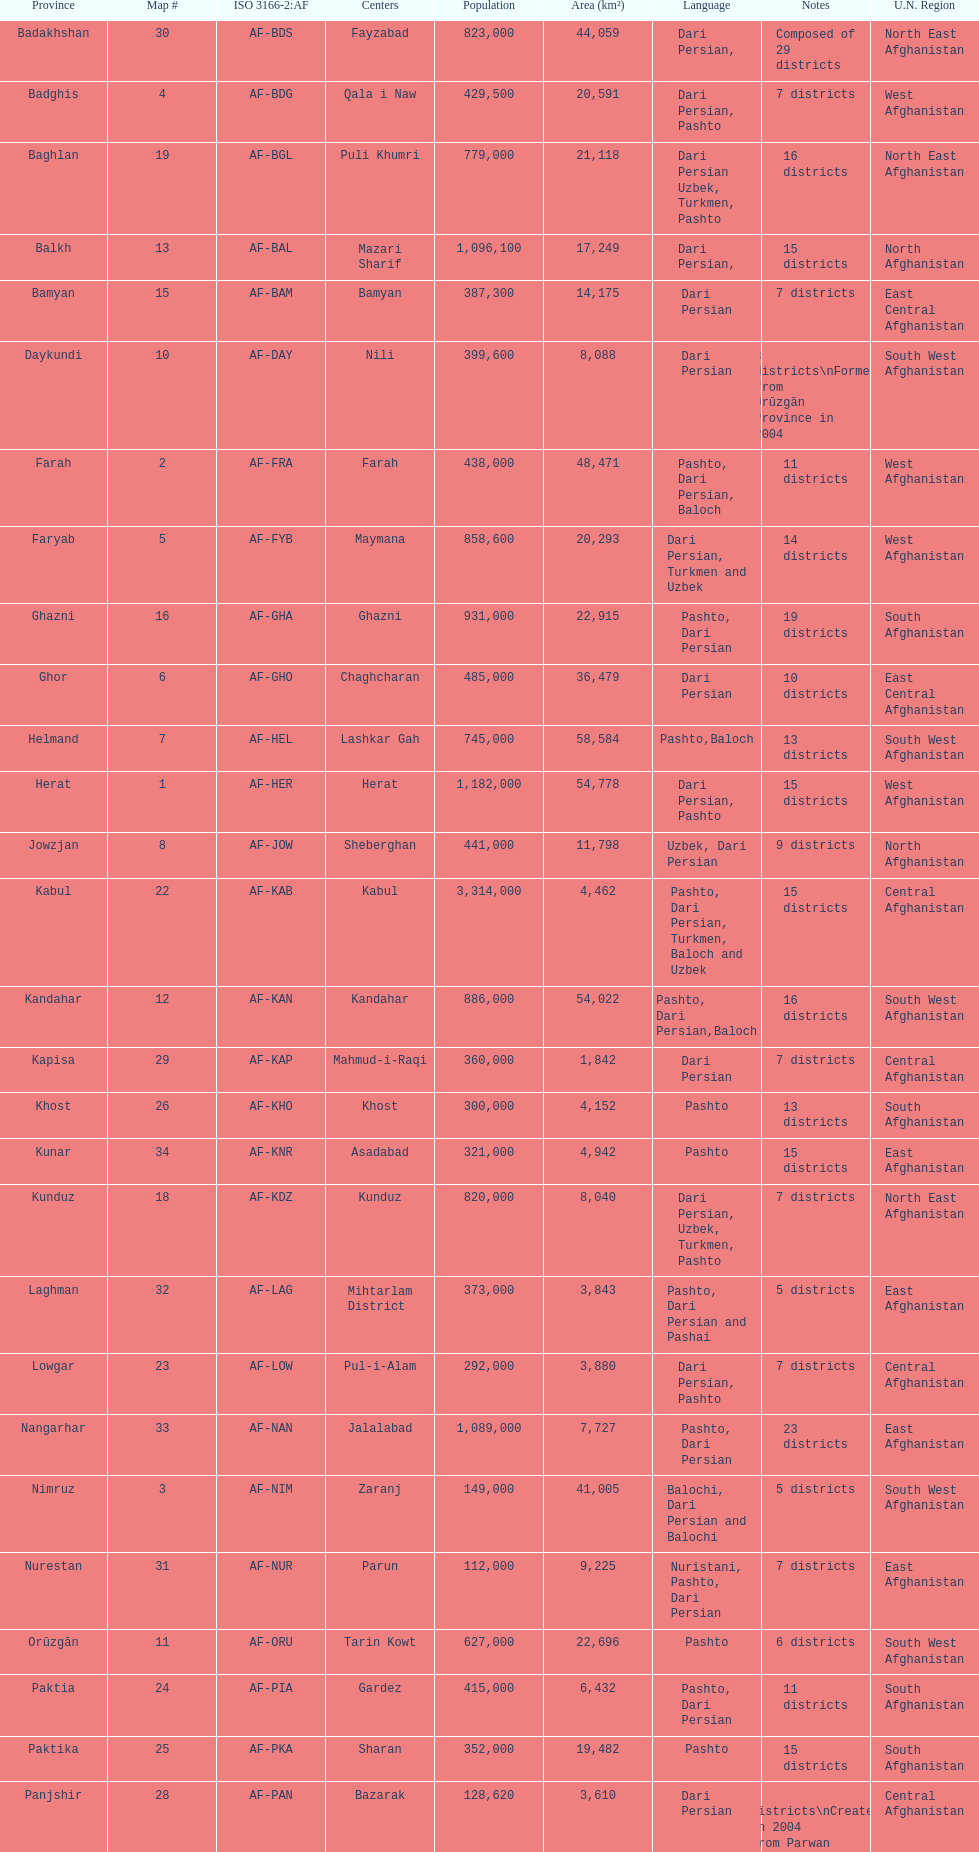Herat has a population of 1,182,000, can you list their languages Dari Persian, Pashto. 